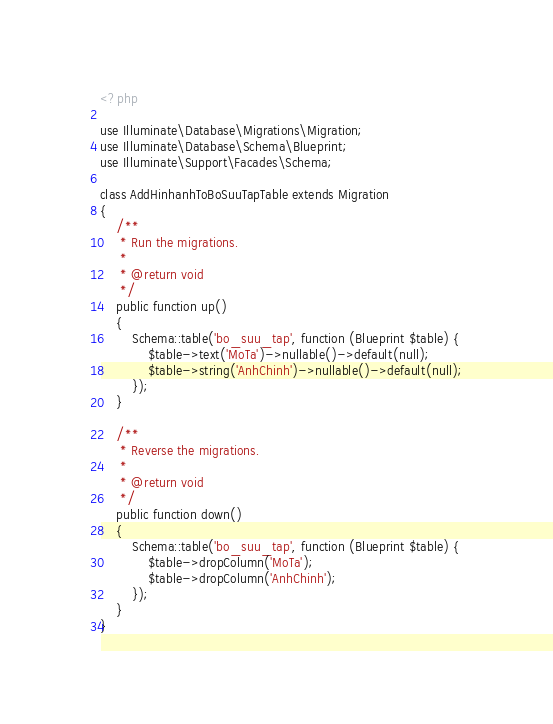Convert code to text. <code><loc_0><loc_0><loc_500><loc_500><_PHP_><?php

use Illuminate\Database\Migrations\Migration;
use Illuminate\Database\Schema\Blueprint;
use Illuminate\Support\Facades\Schema;

class AddHinhanhToBoSuuTapTable extends Migration
{
    /**
     * Run the migrations.
     *
     * @return void
     */
    public function up()
    {
        Schema::table('bo_suu_tap', function (Blueprint $table) {
            $table->text('MoTa')->nullable()->default(null);
            $table->string('AnhChinh')->nullable()->default(null);
        });
    }

    /**
     * Reverse the migrations.
     *
     * @return void
     */
    public function down()
    {
        Schema::table('bo_suu_tap', function (Blueprint $table) {
            $table->dropColumn('MoTa');
            $table->dropColumn('AnhChinh');
        });
    }
}
</code> 